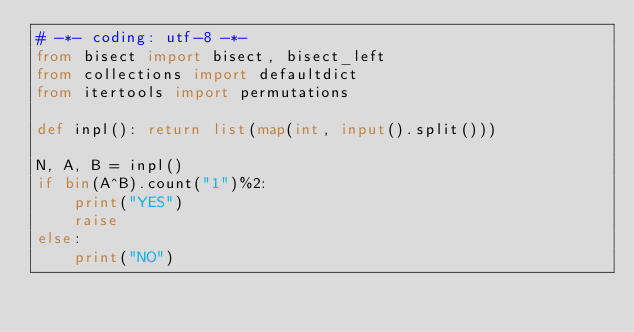Convert code to text. <code><loc_0><loc_0><loc_500><loc_500><_Python_># -*- coding: utf-8 -*-
from bisect import bisect, bisect_left
from collections import defaultdict
from itertools import permutations

def inpl(): return list(map(int, input().split()))

N, A, B = inpl()
if bin(A^B).count("1")%2:
    print("YES")
    raise
else:
    print("NO")</code> 